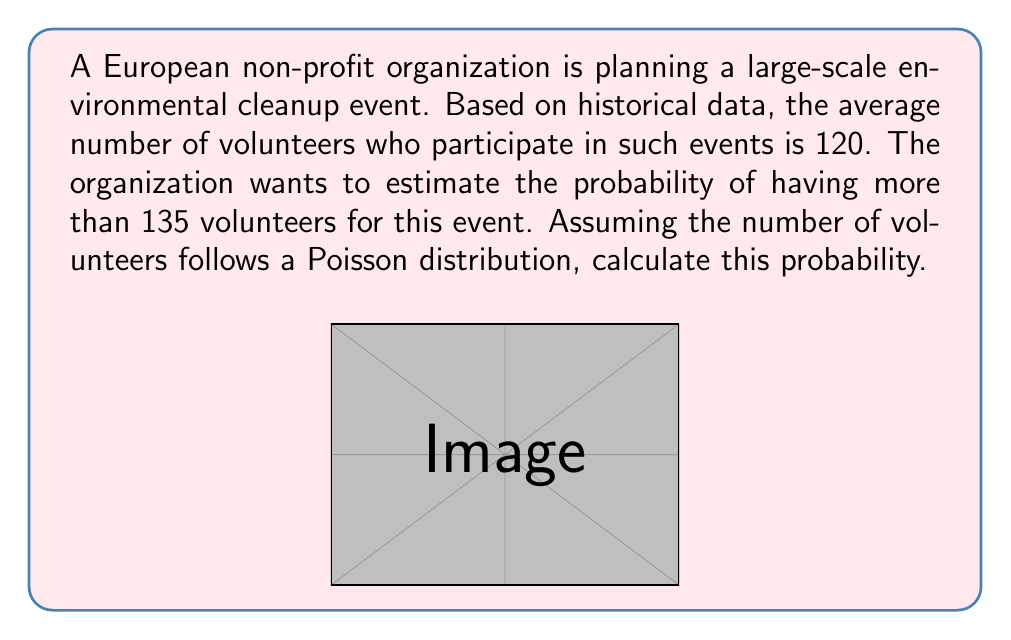Give your solution to this math problem. Let's approach this step-by-step:

1) First, we need to identify the parameters of our Poisson distribution:
   λ (lambda) = average number of volunteers = 120

2) We want to find P(X > 135), where X is the number of volunteers.

3) In a Poisson distribution, P(X > k) = 1 - P(X ≤ k)
   So, P(X > 135) = 1 - P(X ≤ 135)

4) We can calculate P(X ≤ 135) using the cumulative distribution function of the Poisson distribution:

   $$P(X \leq k) = e^{-\lambda} \sum_{i=0}^k \frac{\lambda^i}{i!}$$

5) In this case:
   $$P(X \leq 135) = e^{-120} \sum_{i=0}^{135} \frac{120^i}{i!}$$

6) This sum is difficult to calculate by hand, so we would typically use statistical software or tables. Using such a tool, we find:

   P(X ≤ 135) ≈ 0.9222

7) Therefore:
   P(X > 135) = 1 - P(X ≤ 135) = 1 - 0.9222 ≈ 0.0778

8) Converting to a percentage: 0.0778 * 100% ≈ 7.78%
Answer: 7.78% 